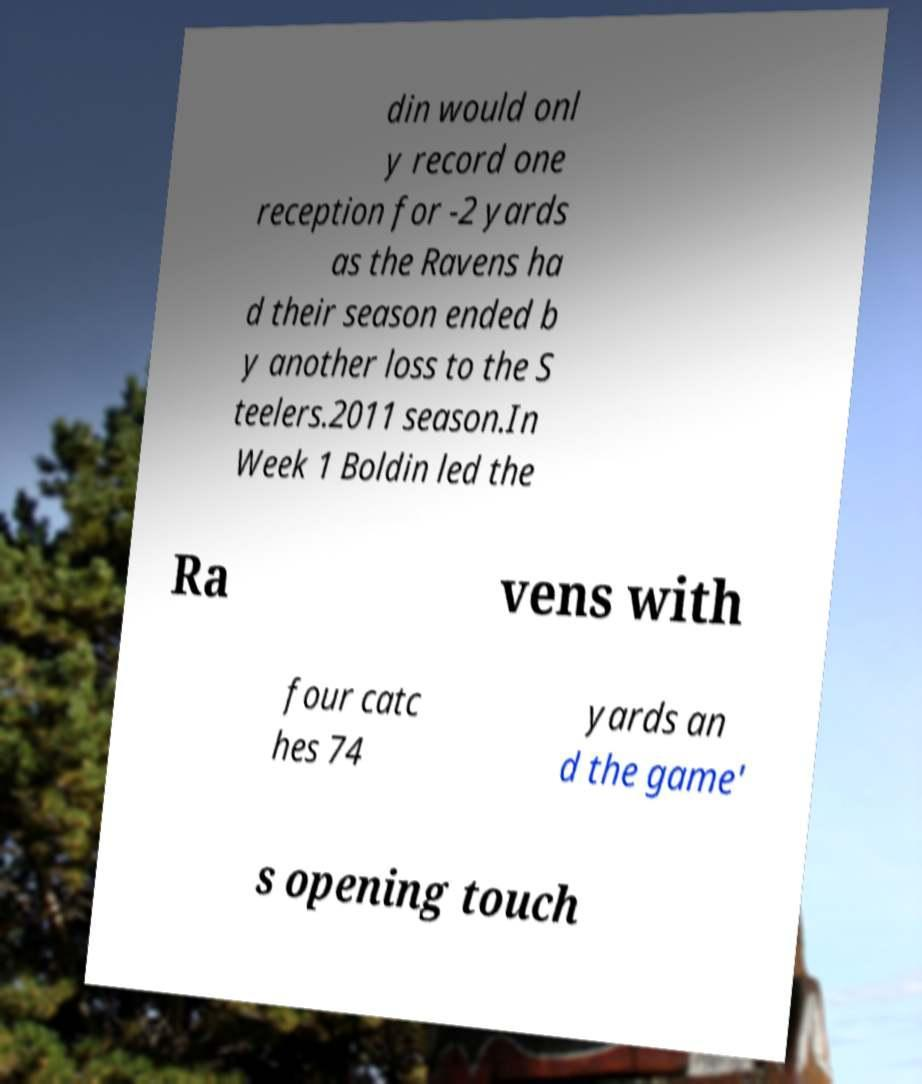Please identify and transcribe the text found in this image. din would onl y record one reception for -2 yards as the Ravens ha d their season ended b y another loss to the S teelers.2011 season.In Week 1 Boldin led the Ra vens with four catc hes 74 yards an d the game' s opening touch 